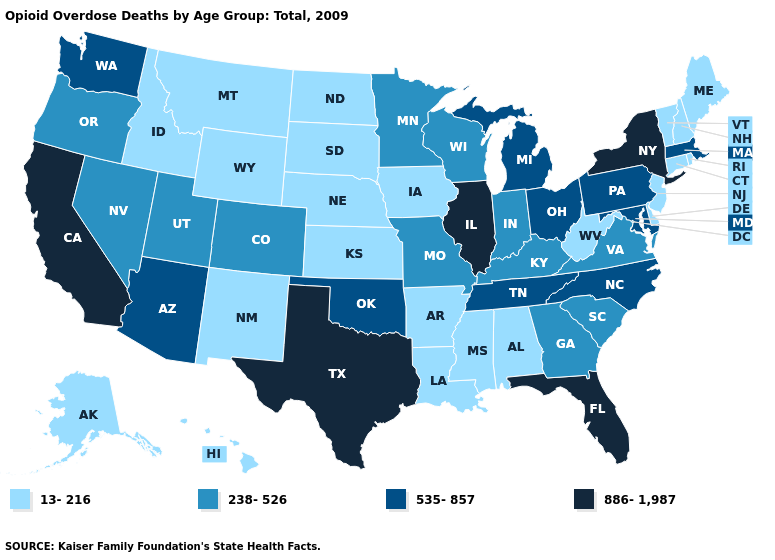How many symbols are there in the legend?
Be succinct. 4. Does the first symbol in the legend represent the smallest category?
Keep it brief. Yes. Name the states that have a value in the range 238-526?
Be succinct. Colorado, Georgia, Indiana, Kentucky, Minnesota, Missouri, Nevada, Oregon, South Carolina, Utah, Virginia, Wisconsin. What is the value of Colorado?
Answer briefly. 238-526. Name the states that have a value in the range 886-1,987?
Give a very brief answer. California, Florida, Illinois, New York, Texas. Does the first symbol in the legend represent the smallest category?
Write a very short answer. Yes. Does Alaska have the highest value in the USA?
Quick response, please. No. What is the lowest value in states that border South Dakota?
Write a very short answer. 13-216. Name the states that have a value in the range 13-216?
Be succinct. Alabama, Alaska, Arkansas, Connecticut, Delaware, Hawaii, Idaho, Iowa, Kansas, Louisiana, Maine, Mississippi, Montana, Nebraska, New Hampshire, New Jersey, New Mexico, North Dakota, Rhode Island, South Dakota, Vermont, West Virginia, Wyoming. What is the value of Missouri?
Give a very brief answer. 238-526. What is the lowest value in states that border Oklahoma?
Short answer required. 13-216. Which states hav the highest value in the MidWest?
Be succinct. Illinois. Name the states that have a value in the range 238-526?
Short answer required. Colorado, Georgia, Indiana, Kentucky, Minnesota, Missouri, Nevada, Oregon, South Carolina, Utah, Virginia, Wisconsin. Does New Mexico have a lower value than Ohio?
Be succinct. Yes. What is the value of Wyoming?
Answer briefly. 13-216. 